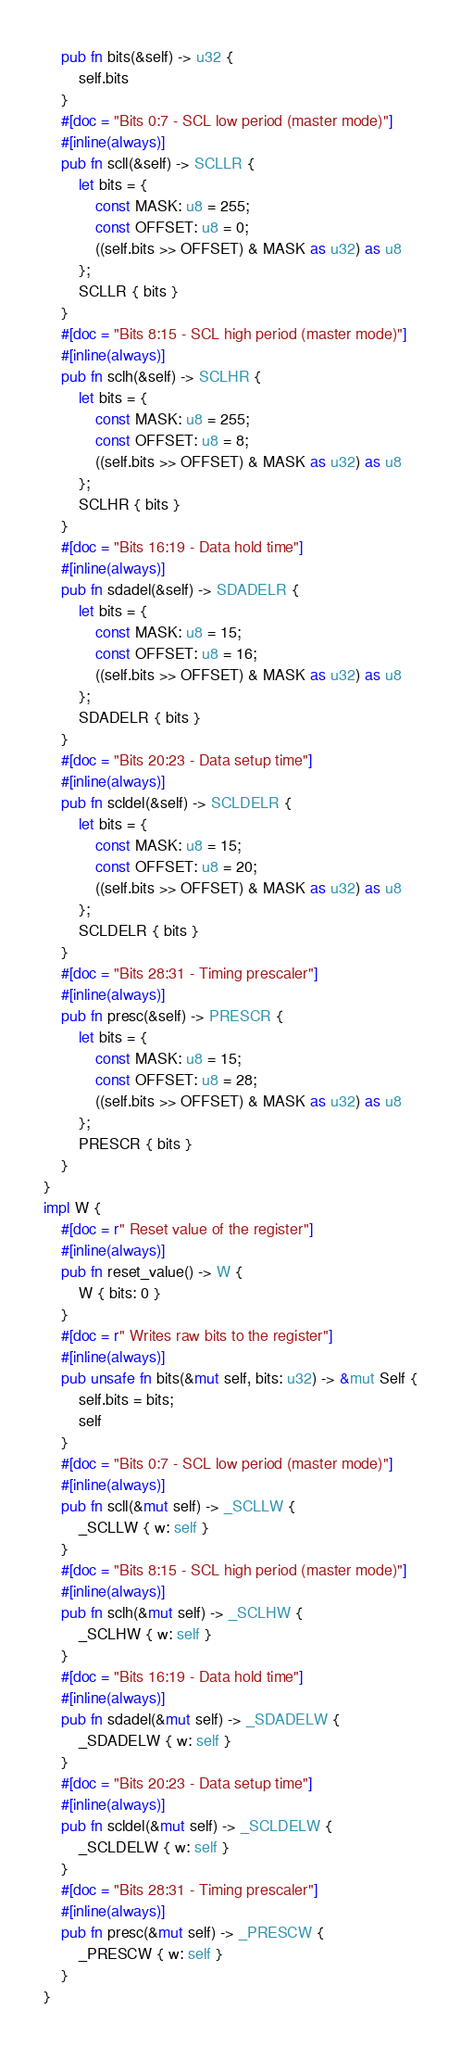<code> <loc_0><loc_0><loc_500><loc_500><_Rust_>    pub fn bits(&self) -> u32 {
        self.bits
    }
    #[doc = "Bits 0:7 - SCL low period (master mode)"]
    #[inline(always)]
    pub fn scll(&self) -> SCLLR {
        let bits = {
            const MASK: u8 = 255;
            const OFFSET: u8 = 0;
            ((self.bits >> OFFSET) & MASK as u32) as u8
        };
        SCLLR { bits }
    }
    #[doc = "Bits 8:15 - SCL high period (master mode)"]
    #[inline(always)]
    pub fn sclh(&self) -> SCLHR {
        let bits = {
            const MASK: u8 = 255;
            const OFFSET: u8 = 8;
            ((self.bits >> OFFSET) & MASK as u32) as u8
        };
        SCLHR { bits }
    }
    #[doc = "Bits 16:19 - Data hold time"]
    #[inline(always)]
    pub fn sdadel(&self) -> SDADELR {
        let bits = {
            const MASK: u8 = 15;
            const OFFSET: u8 = 16;
            ((self.bits >> OFFSET) & MASK as u32) as u8
        };
        SDADELR { bits }
    }
    #[doc = "Bits 20:23 - Data setup time"]
    #[inline(always)]
    pub fn scldel(&self) -> SCLDELR {
        let bits = {
            const MASK: u8 = 15;
            const OFFSET: u8 = 20;
            ((self.bits >> OFFSET) & MASK as u32) as u8
        };
        SCLDELR { bits }
    }
    #[doc = "Bits 28:31 - Timing prescaler"]
    #[inline(always)]
    pub fn presc(&self) -> PRESCR {
        let bits = {
            const MASK: u8 = 15;
            const OFFSET: u8 = 28;
            ((self.bits >> OFFSET) & MASK as u32) as u8
        };
        PRESCR { bits }
    }
}
impl W {
    #[doc = r" Reset value of the register"]
    #[inline(always)]
    pub fn reset_value() -> W {
        W { bits: 0 }
    }
    #[doc = r" Writes raw bits to the register"]
    #[inline(always)]
    pub unsafe fn bits(&mut self, bits: u32) -> &mut Self {
        self.bits = bits;
        self
    }
    #[doc = "Bits 0:7 - SCL low period (master mode)"]
    #[inline(always)]
    pub fn scll(&mut self) -> _SCLLW {
        _SCLLW { w: self }
    }
    #[doc = "Bits 8:15 - SCL high period (master mode)"]
    #[inline(always)]
    pub fn sclh(&mut self) -> _SCLHW {
        _SCLHW { w: self }
    }
    #[doc = "Bits 16:19 - Data hold time"]
    #[inline(always)]
    pub fn sdadel(&mut self) -> _SDADELW {
        _SDADELW { w: self }
    }
    #[doc = "Bits 20:23 - Data setup time"]
    #[inline(always)]
    pub fn scldel(&mut self) -> _SCLDELW {
        _SCLDELW { w: self }
    }
    #[doc = "Bits 28:31 - Timing prescaler"]
    #[inline(always)]
    pub fn presc(&mut self) -> _PRESCW {
        _PRESCW { w: self }
    }
}
</code> 